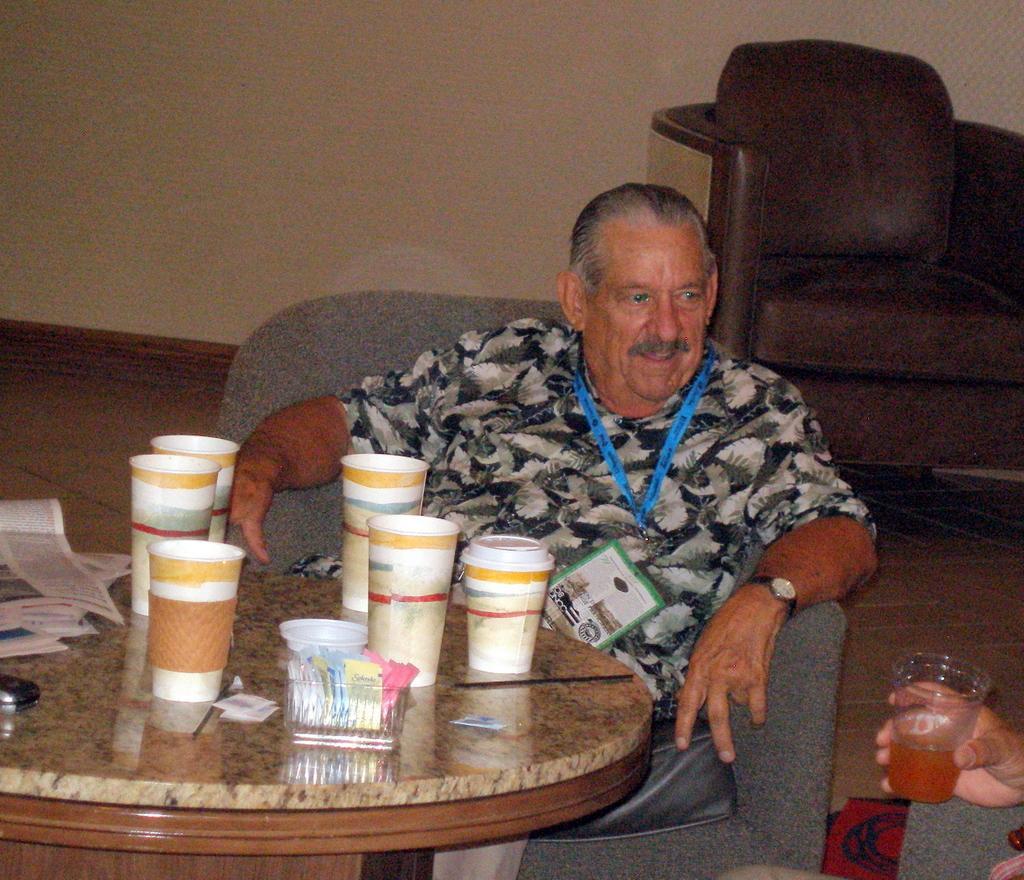Can you describe this image briefly? In this picture we can see a man is sitting on a chair and in front of the man there is a table and on the table there are caps, papers and other things. On the right side of the table, we can see another person is holding a glass. Behind the people there is another chair and a wall. 